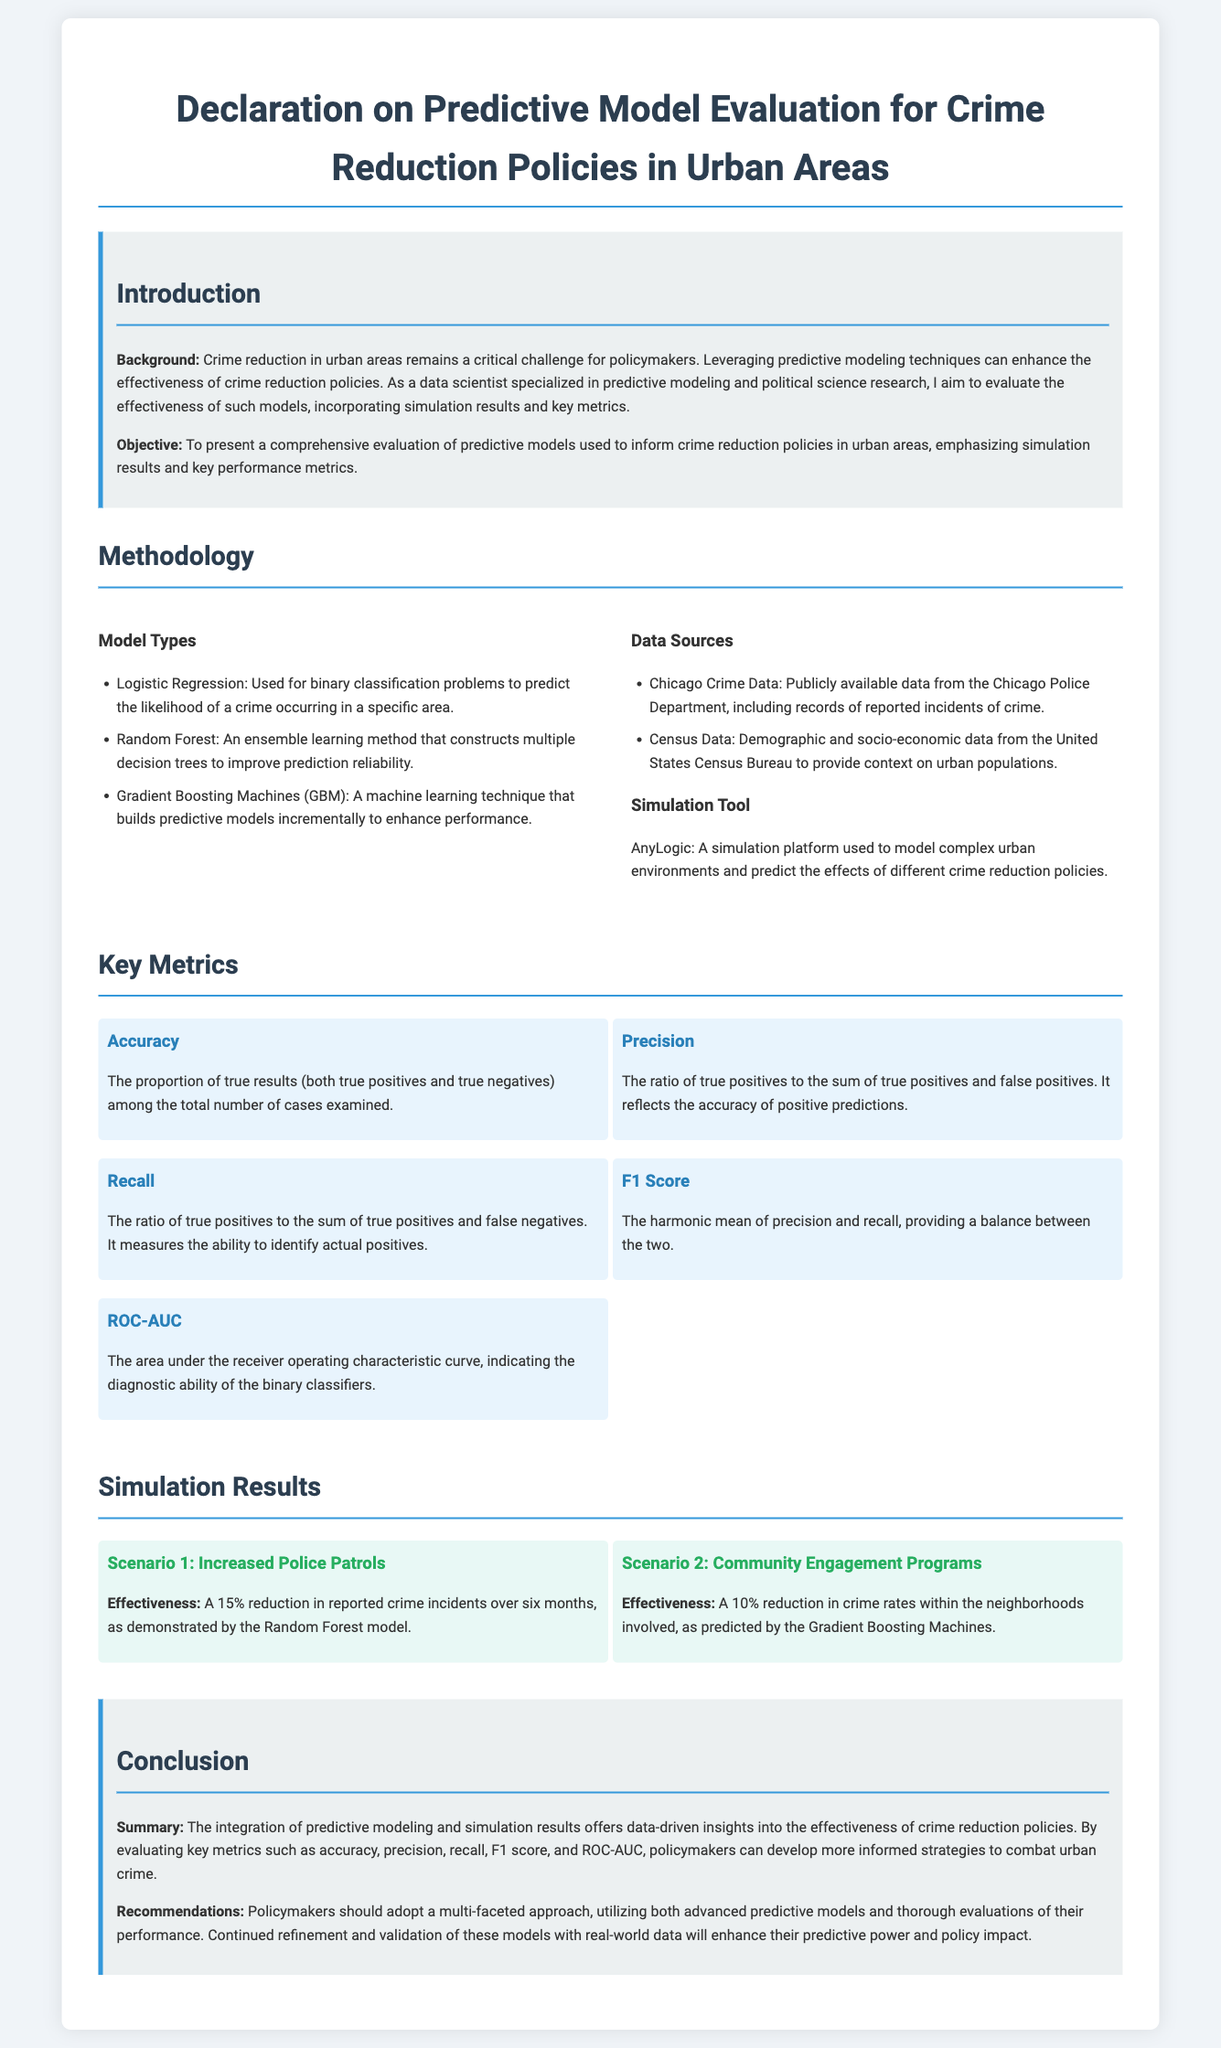what is the main objective of the declaration? The main objective is to present a comprehensive evaluation of predictive models used to inform crime reduction policies in urban areas.
Answer: comprehensive evaluation of predictive models which model type is used for binary classification problems? Logistic Regression is specified as a model type used for binary classification problems.
Answer: Logistic Regression what platform is mentioned as the simulation tool? The simulation tool mentioned is AnyLogic.
Answer: AnyLogic what percentage reduction in reported crime incidents was observed in Scenario 1? Scenario 1 reported a 15% reduction in reported crime incidents.
Answer: 15% what key metric reflects the accuracy of positive predictions? The metric that reflects the accuracy of positive predictions is Precision.
Answer: Precision which model predicted a 10% reduction in crime rates through community engagement? The Gradient Boosting Machines predicted a 10% reduction in crime rates due to community engagement programs.
Answer: Gradient Boosting Machines what are the two data sources mentioned in the document? The two data sources are Chicago Crime Data and Census Data.
Answer: Chicago Crime Data, Census Data what is the F1 Score? The F1 Score is the harmonic mean of precision and recall.
Answer: harmonic mean of precision and recall what should policymakers adopt according to the recommendations? Policymakers should adopt a multi-faceted approach, utilizing advanced predictive models and thorough evaluations.
Answer: multi-faceted approach 